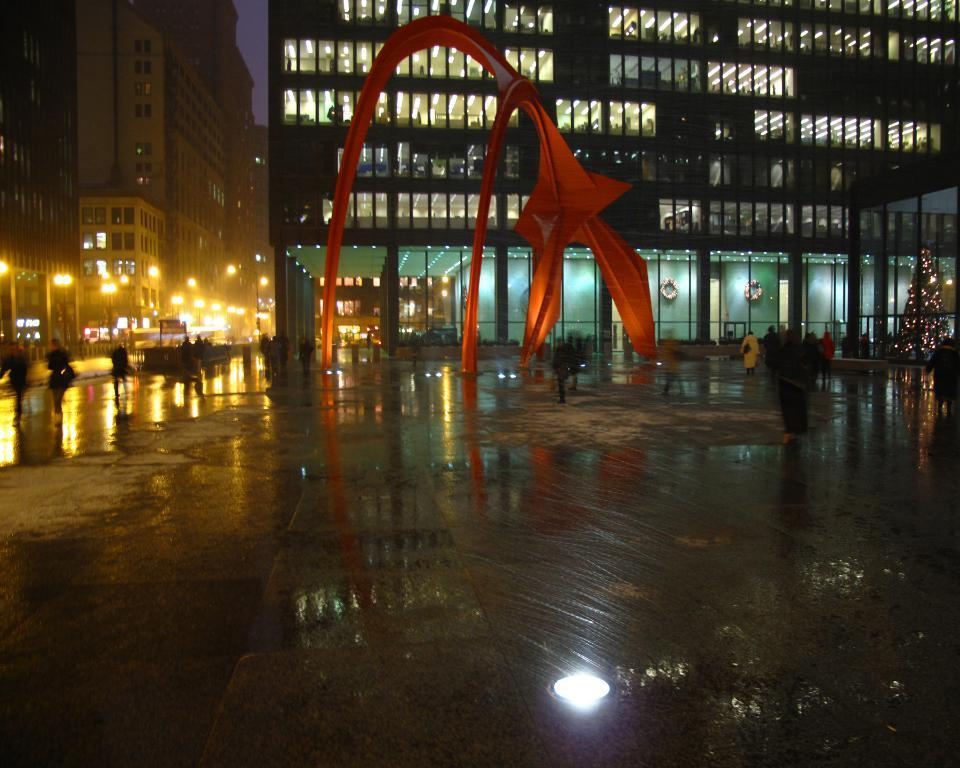What type of artwork is featured in the image? There is a modern sculpture in the image. What else can be seen in the image besides the sculpture? There are buildings, lights, poles, a group of people walking, a tree decorated with lights, and the sky visible in the image. What religion is being practiced by the people in the image? There is no indication of any religious practice in the image; it features a modern sculpture, buildings, lights, poles, a group of people walking, a tree decorated with lights, and the sky. What time of day is depicted in the image? The time of day cannot be determined from the image; it only shows a modern sculpture, buildings, lights, poles, a group of people walking, a tree decorated with lights, and the sky. 